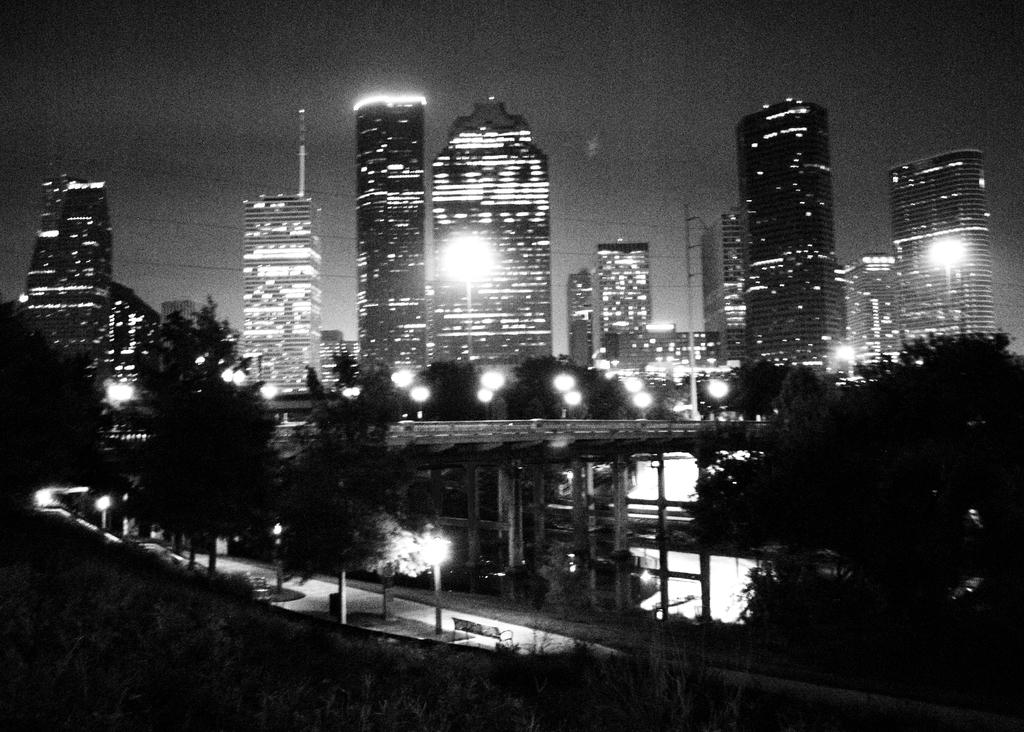What is the color scheme of the image? The image is black and white. What can be seen in the foreground of the image? There is a flyover, trees, lights, and a bench in the foreground of the image. What is visible in the background of the image? Skyscrapers, lights, trees, and the sky are visible in the background of the image. What time of day is it in the image, considering the presence of afternoon light? The image is black and white, so it is not possible to determine the time of day based on the presence of afternoon light. How does the flyover slow down or stop in the image, considering the presence of a brake? There is no brake present in the image, and the flyover is a stationary structure. 